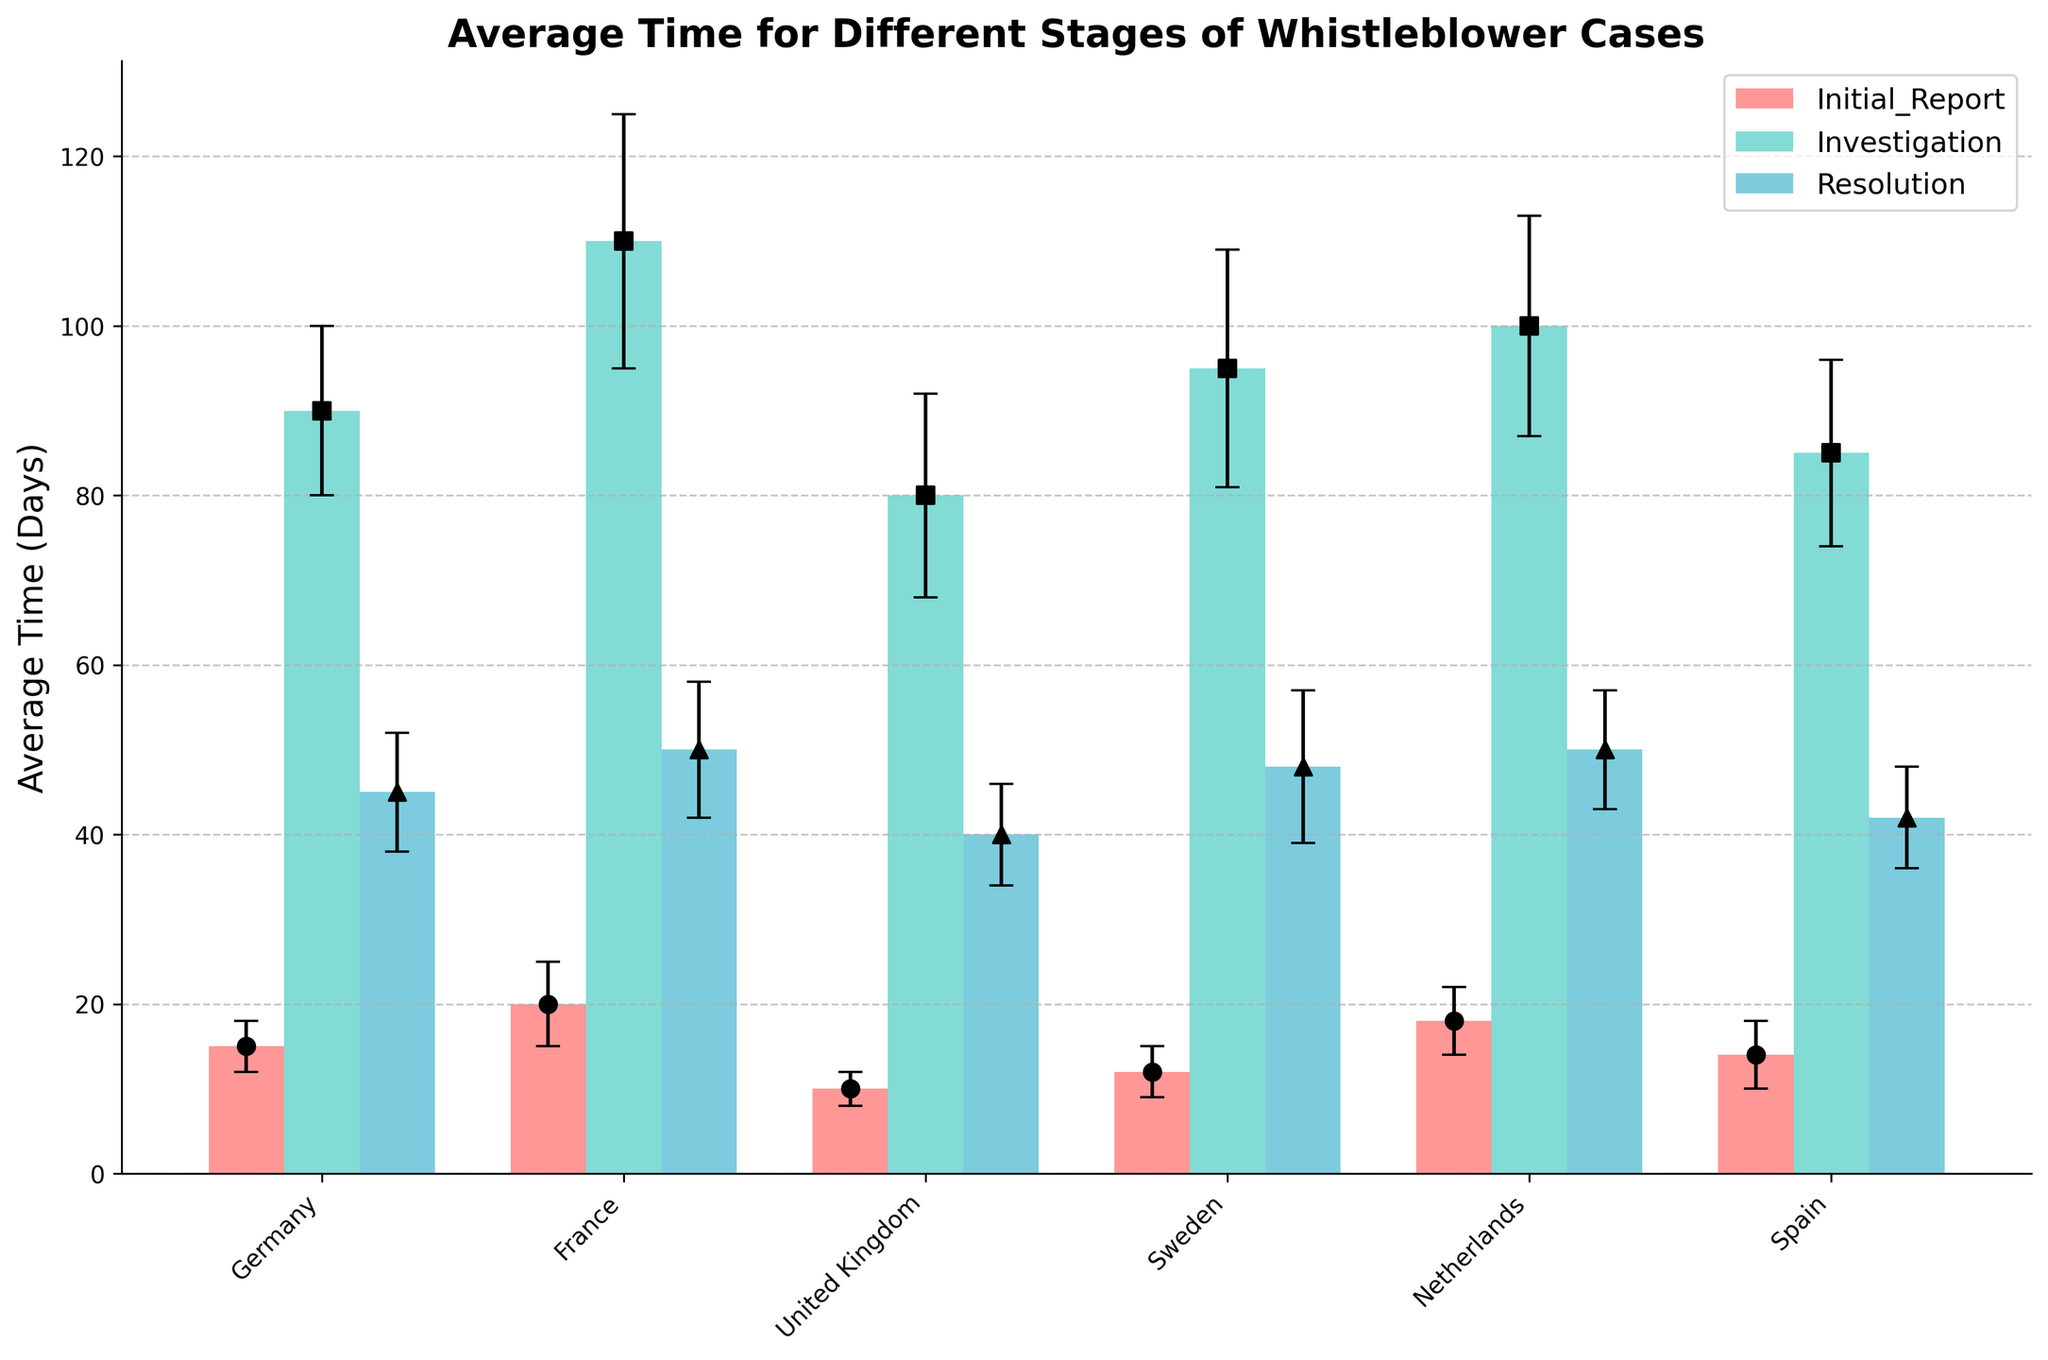What's the title of the figure? The title is usually placed at the top of the figure, centered, and in a larger or bold font.
Answer: Average Time for Different Stages of Whistleblower Cases What is the y-axis label? The label for the y-axis is located along the vertical axis, usually written in a rotated fashion.
Answer: Average Time (Days) Which country has the shortest average time for the Initial Report stage? Locate the bar representing each country's Initial Report stage and compare the heights. The shortest bar corresponds to the shortest average time.
Answer: United Kingdom What is the average time taken for the Investigation stage in Spain? Identify the bar for Spain in the Investigation stage and read the value associated with it.
Answer: 85 days How much longer, on average, does it take to resolve cases in Germany compared to the United Kingdom? Find the average times for the Resolution stage in Germany and the United Kingdom, then subtract the UK's value from Germany's value (45 - 40).
Answer: 5 days Which stage generally takes the longest across all countries? Evaluate the height of the bars across all stages and countries. The stage with the consistently highest values will be the Investigation stage.
Answer: Investigation What is the widest error bar among all bars for the France dataset? Look at the error bars for France in all stages and compare their lengths. The widest error bar indicates the largest standard deviation.
Answer: Investigation (15 days) By how many days does the average time for the Investigation stage in the Netherlands exceed that in the United Kingdom? Subtract the UK's average time for the Investigation stage from that of the Netherlands (100 - 80).
Answer: 20 days In which country does the Resolution stage take the least time, on average? Examine the Resolution stage bars for each country and identify the shortest one.
Answer: United Kingdom How does the average time for the Initial Report stage in Sweden compare to the same stage in Germany? Compare the heights of the bars for the Initial Report stage in Sweden and Germany. Subtract Germany's value from Sweden's value (12 - 15).
Answer: 3 days less 